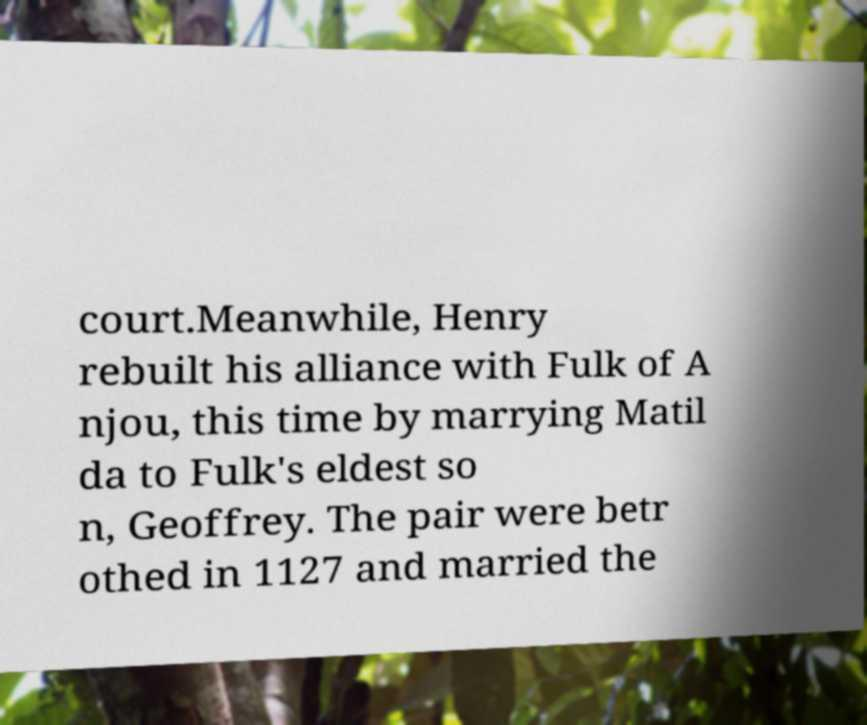Please read and relay the text visible in this image. What does it say? court.Meanwhile, Henry rebuilt his alliance with Fulk of A njou, this time by marrying Matil da to Fulk's eldest so n, Geoffrey. The pair were betr othed in 1127 and married the 